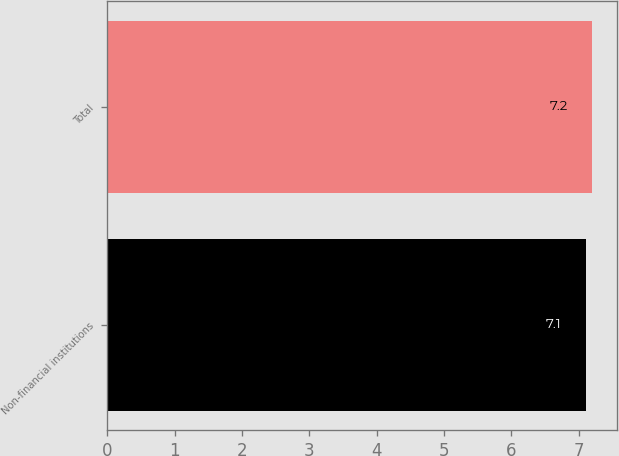<chart> <loc_0><loc_0><loc_500><loc_500><bar_chart><fcel>Non-financial institutions<fcel>Total<nl><fcel>7.1<fcel>7.2<nl></chart> 